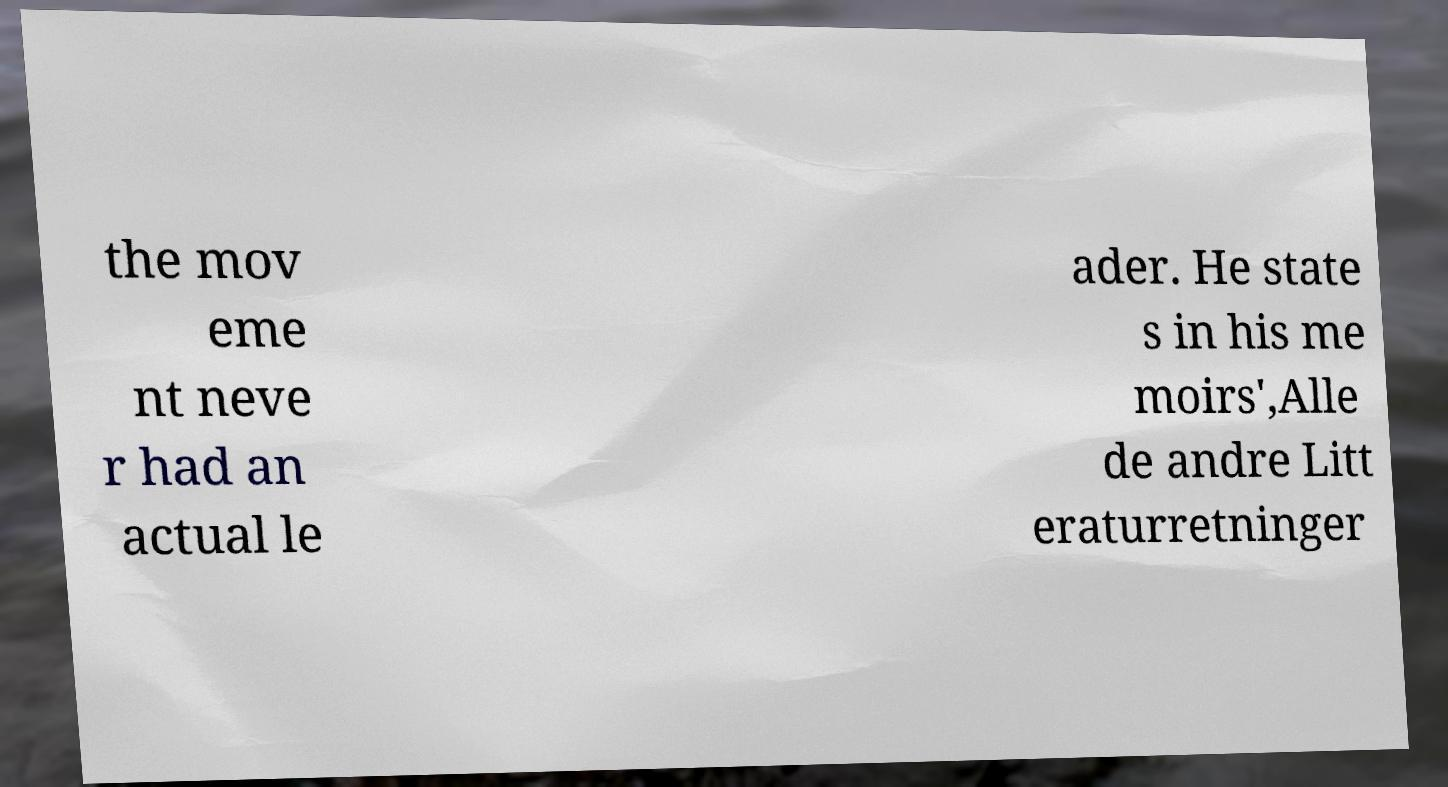Please read and relay the text visible in this image. What does it say? the mov eme nt neve r had an actual le ader. He state s in his me moirs',Alle de andre Litt eraturretninger 